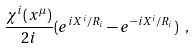Convert formula to latex. <formula><loc_0><loc_0><loc_500><loc_500>\frac { \chi ^ { i } ( x ^ { \mu } ) } { 2 i } ( e ^ { i X ^ { i } / R _ { i } } - e ^ { - i X ^ { i } / R _ { i } } ) \ ,</formula> 